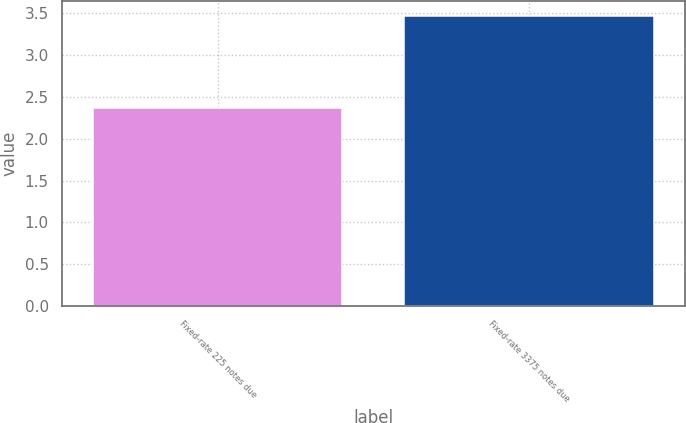<chart> <loc_0><loc_0><loc_500><loc_500><bar_chart><fcel>Fixed-rate 225 notes due<fcel>Fixed-rate 3375 notes due<nl><fcel>2.37<fcel>3.47<nl></chart> 